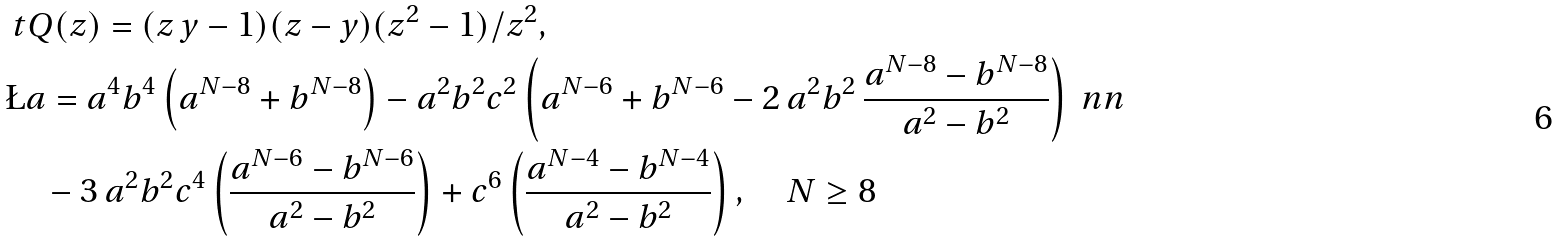Convert formula to latex. <formula><loc_0><loc_0><loc_500><loc_500>& \ t Q ( z ) = ( z \, y - 1 ) ( z - y ) ( z ^ { 2 } - 1 ) / z ^ { 2 } , \\ & \L a = { a } ^ { 4 } { b } ^ { 4 } \left ( a ^ { N - 8 } + b ^ { N - 8 } \right ) - { a } ^ { 2 } { b } ^ { 2 } { c } ^ { 2 } \left ( { a } ^ { N - 6 } + { b } ^ { N - 6 } - 2 \, { a } ^ { 2 } { b } ^ { 2 } \, \frac { { a } ^ { N - 8 } - { b } ^ { N - 8 } } { { a } ^ { 2 } - { b } ^ { 2 } } \right ) \ n n \\ & \quad - 3 \, { a } ^ { 2 } { b } ^ { 2 } { c } ^ { 4 } \left ( \frac { { a } ^ { N - 6 } - { b } ^ { N - 6 } } { { a } ^ { 2 } - { b } ^ { 2 } } \right ) + c ^ { 6 } \left ( \frac { { a } ^ { N - 4 } - { b } ^ { N - 4 } } { { a } ^ { 2 } - { b } ^ { 2 } } \right ) , \quad N \geq 8</formula> 